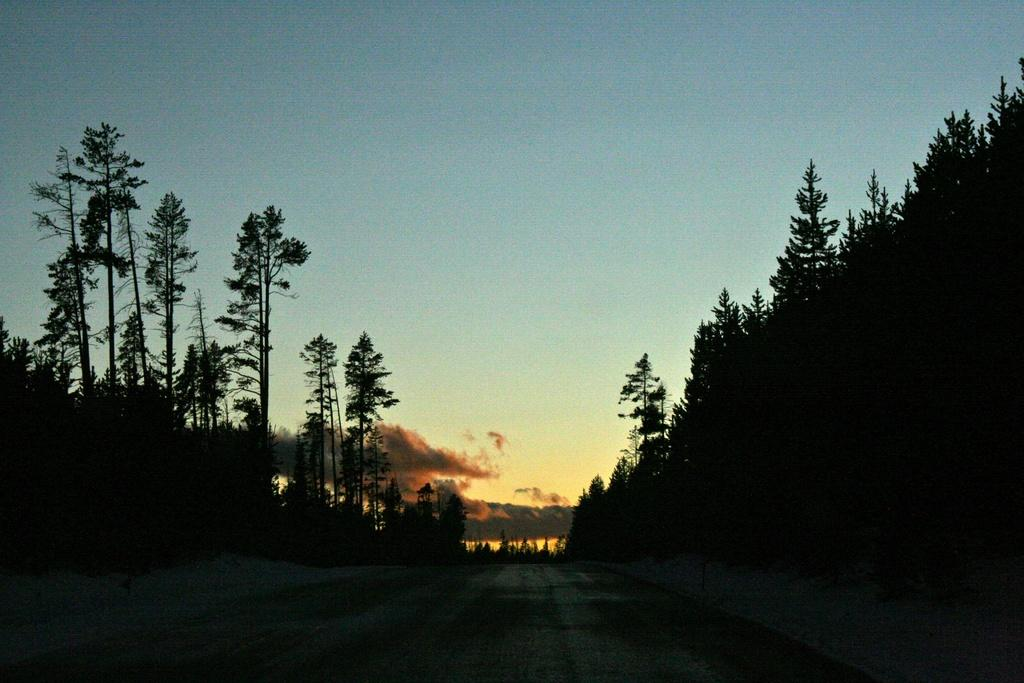What is the main feature in the foreground of the image? There is a road in the foreground of the image. What can be seen on both sides of the road? There are trees on either side of the road. What is visible at the top of the image? The sky is visible at the top of the image. What type of drum is being played by the achiever in the image? There is no achiever or drum present in the image. What belief system is represented by the symbols on the road in the image? There are no symbols or belief systems represented on the road in the image. 